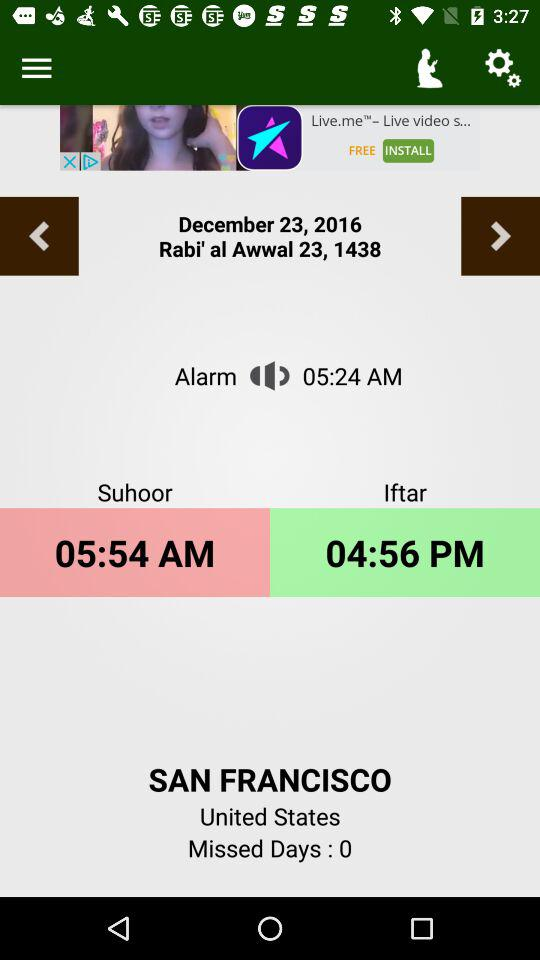When is the time for "Suhoor"? The time for "Suhoor" is 05:54 AM. 